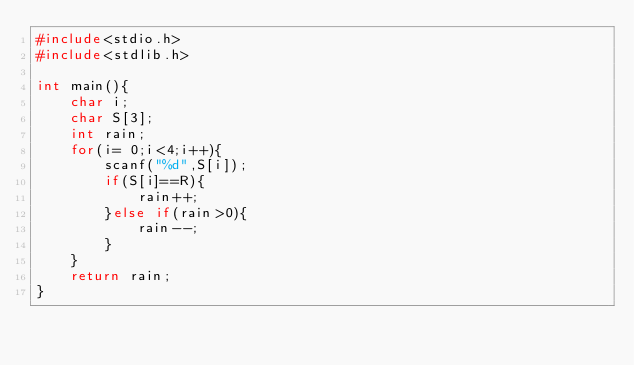Convert code to text. <code><loc_0><loc_0><loc_500><loc_500><_C_>#include<stdio.h>
#include<stdlib.h>

int main(){
    char i;
    char S[3];
    int rain;
    for(i= 0;i<4;i++){
        scanf("%d",S[i]);
        if(S[i]==R){
            rain++;
        }else if(rain>0){
            rain--;
        }
    }
    return rain;
}
</code> 